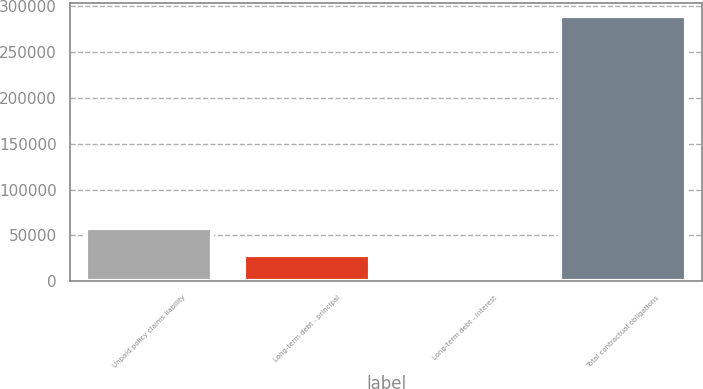Convert chart to OTSL. <chart><loc_0><loc_0><loc_500><loc_500><bar_chart><fcel>Unpaid policy claims liability<fcel>Long-term debt - principal<fcel>Long-term debt - interest<fcel>Total contractual obligations<nl><fcel>57898.6<fcel>28981.3<fcel>64<fcel>289237<nl></chart> 